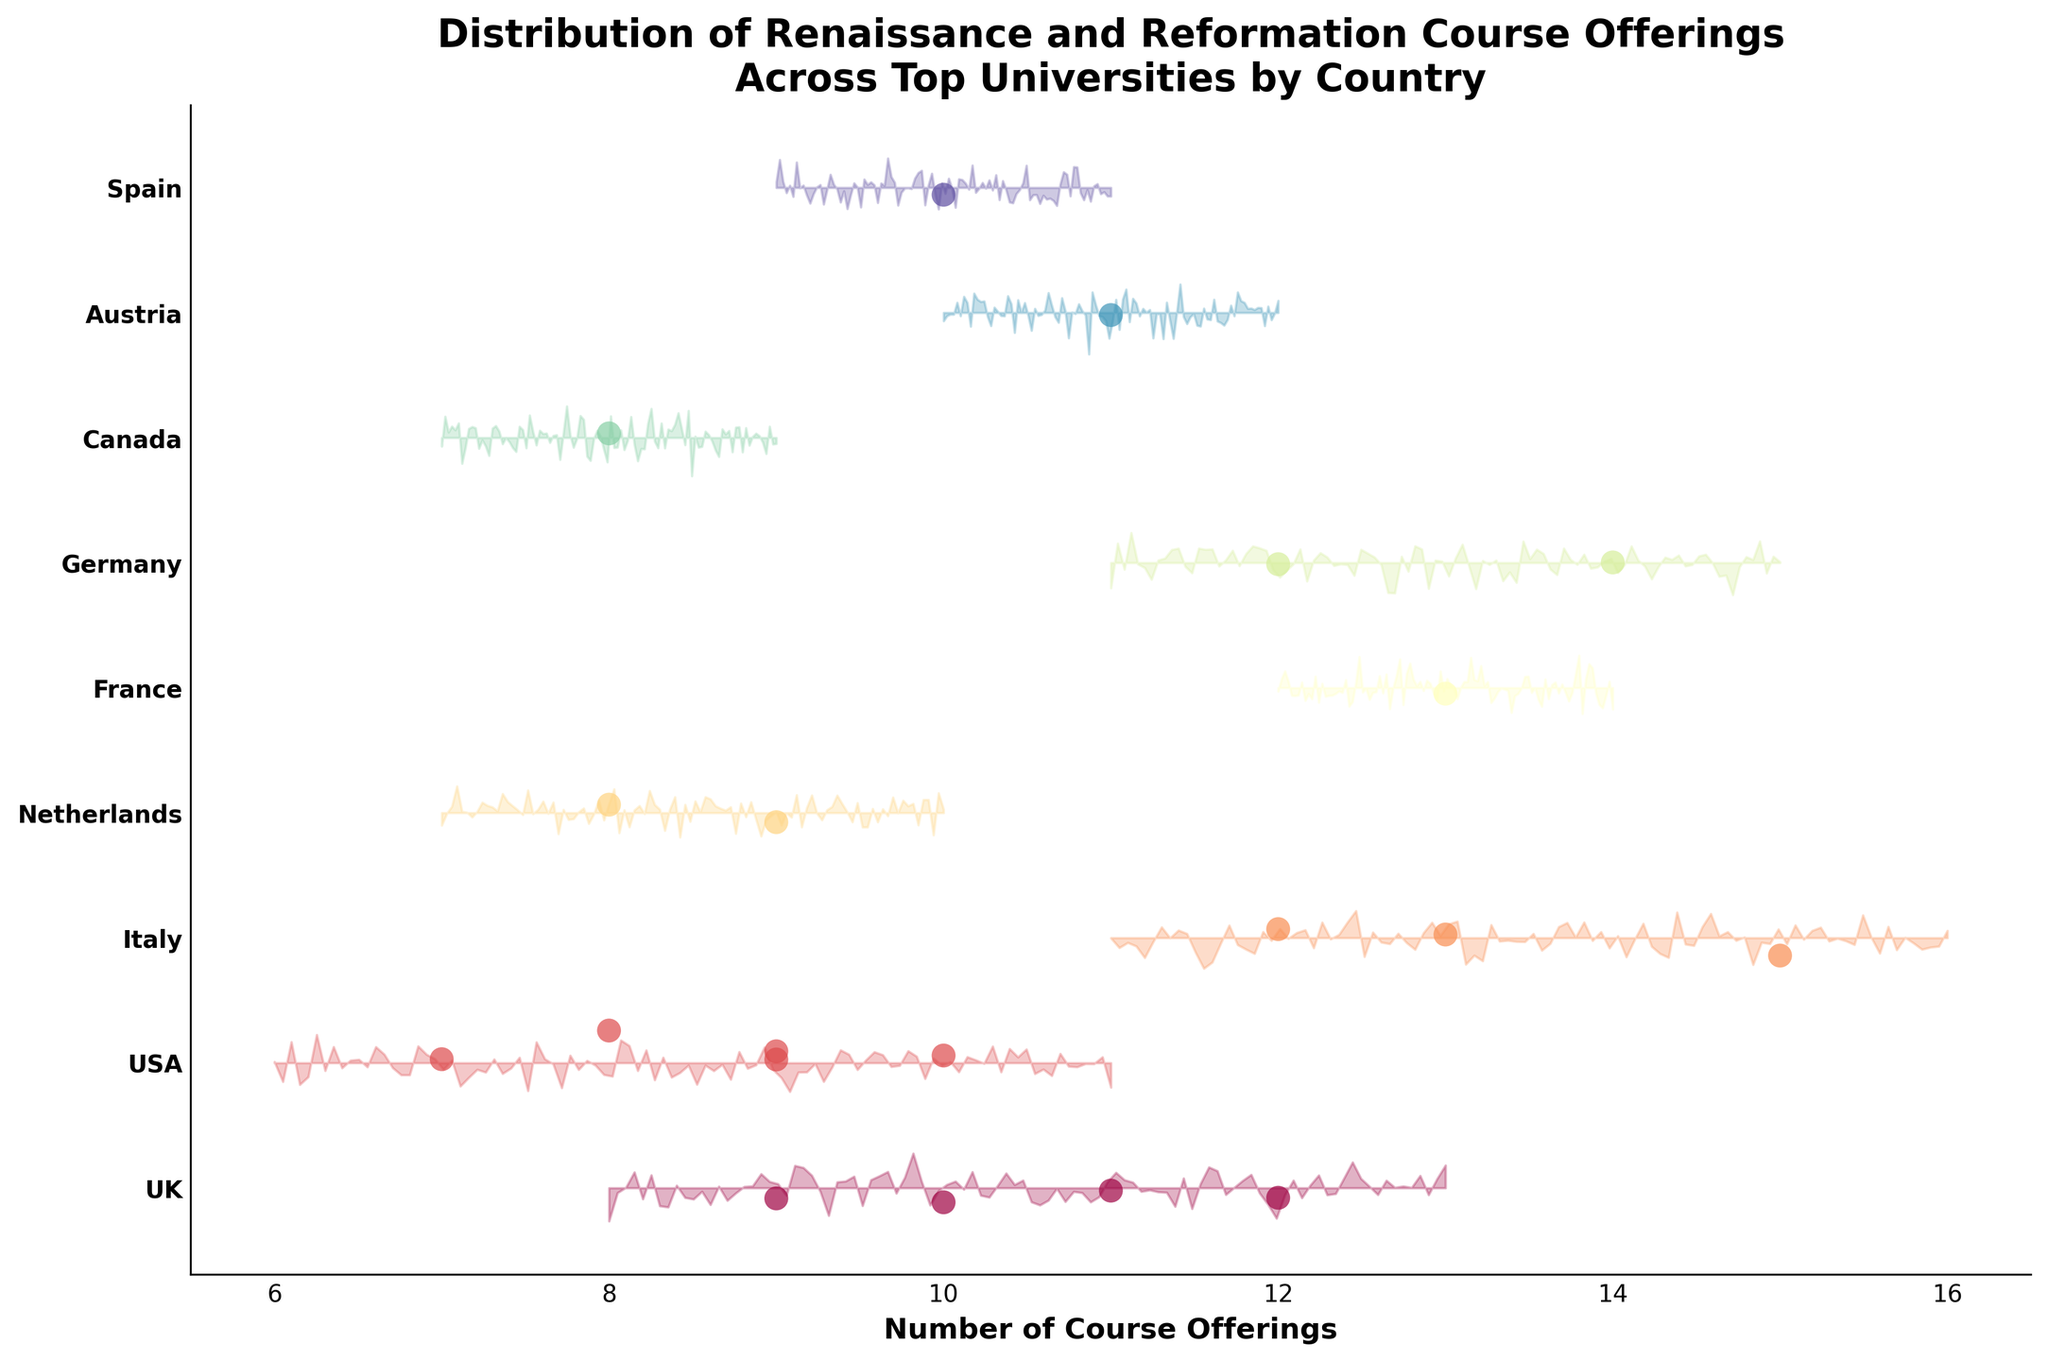What is the title of the plot? The title should be located at the top of the plot. It provides a summary of what the plot represents. In this case, it is "Distribution of Renaissance and Reformation Course Offerings Across Top Universities by Country".
Answer: Distribution of Renaissance and Reformation Course Offerings Across Top Universities by Country How many countries are represented in the plot? To determine the number of countries, count the unique countries along the y-axis. Each country should have its own label. In the plot, there are several countries such as the UK, USA, Italy, and others.
Answer: 8 Which country has the highest number of course offerings on average? Look for the country where the data points (scatter points) are clustered towards the higher end of the x-axis. This will give an indication of which country tends to have more course offerings. Germany and Italy have data points clustered toward higher values.
Answer: Italy Do any countries have the same number of course offerings? To answer this, you should look at the x-coordinates of the data points and see if any country's data points align vertically with the same x-value. Countries like the UK and USA both have universities with 9 course offerings.
Answer: Yes Which country has the widest distribution of course offerings? Examine the spread of the course offerings (x-values) for each country's data points. The country with the largest spread will have the widest distribution. The USA, for instance, shows a wide range from 7 to 10.
Answer: USA What is the minimum number of course offerings across all countries? To find this, identify the lowest x-value among all data points in the plot. The minimum data point is around 7 from Stanford University in the USA.
Answer: 7 Which country has the most universities represented? Look at the y-axis labels and count the number of unique universities for each country. Italy has multiple universities like the University of Bologna, University of Florence, and University of Padua.
Answer: Italy How do course offerings in Canada compare to those in the Netherlands? Compare the data points for Canada and the Netherlands along the x-axis. Canada has offerings around 8, while the Netherlands has offerings around 8 and 9. The Netherlands shows slightly more spread.
Answer: Close, with Netherlands slightly higher Which country has the least variation in course offerings? Determine the country with data points closest together (least spread on the x-axis). The UK's universities generally cluster between 9 and 12 offerings.
Answer: UK What is the average number of course offerings in UK universities? Calculate the average by summing the UK course offerings and dividing by the number of UK universities: (12 + 11 + 10 + 9) / 4 = 42 / 4 = 10.5.
Answer: 10.5 